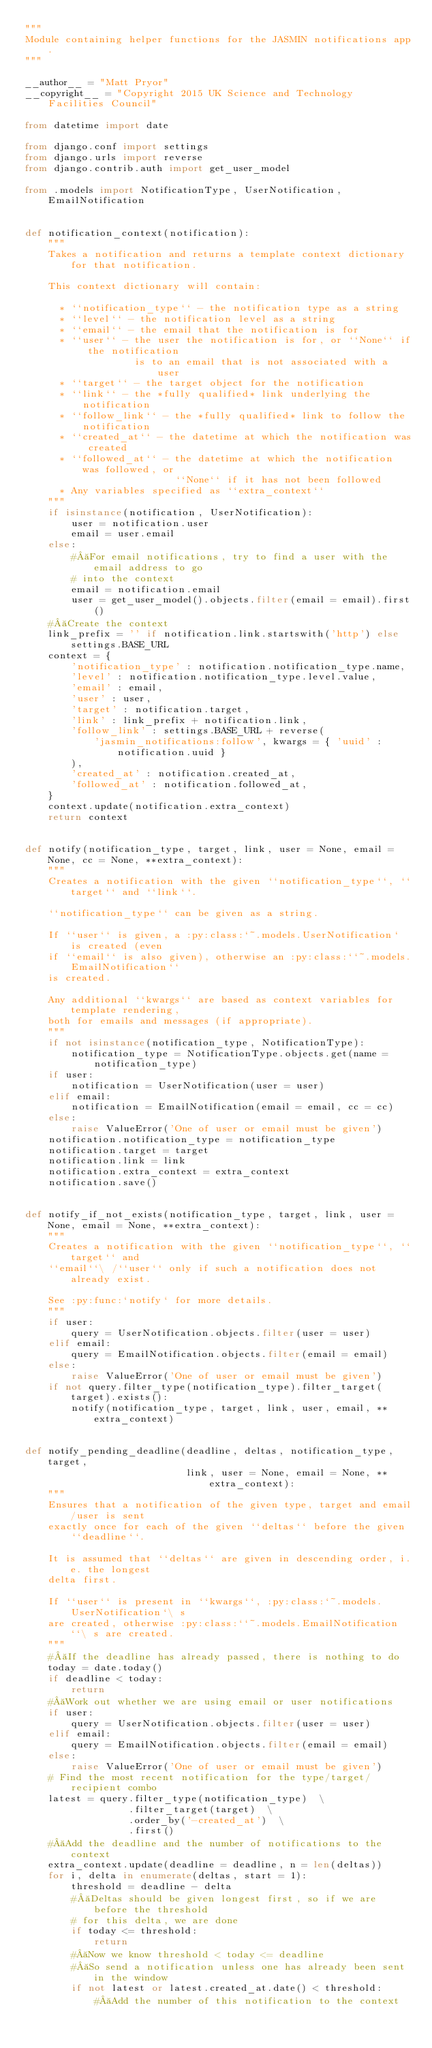Convert code to text. <code><loc_0><loc_0><loc_500><loc_500><_Python_>"""
Module containing helper functions for the JASMIN notifications app.
"""

__author__ = "Matt Pryor"
__copyright__ = "Copyright 2015 UK Science and Technology Facilities Council"

from datetime import date

from django.conf import settings
from django.urls import reverse
from django.contrib.auth import get_user_model

from .models import NotificationType, UserNotification, EmailNotification


def notification_context(notification):
    """
    Takes a notification and returns a template context dictionary for that notification.

    This context dictionary will contain:

      * ``notification_type`` - the notification type as a string
      * ``level`` - the notification level as a string
      * ``email`` - the email that the notification is for
      * ``user`` - the user the notification is for, or ``None`` if the notification
                   is to an email that is not associated with a user
      * ``target`` - the target object for the notification
      * ``link`` - the *fully qualified* link underlying the notification
      * ``follow_link`` - the *fully qualified* link to follow the notification
      * ``created_at`` - the datetime at which the notification was created
      * ``followed_at`` - the datetime at which the notification was followed, or
                          ``None`` if it has not been followed
      * Any variables specified as ``extra_context``
    """
    if isinstance(notification, UserNotification):
        user = notification.user
        email = user.email
    else:
        # For email notifications, try to find a user with the email address to go
        # into the context
        email = notification.email
        user = get_user_model().objects.filter(email = email).first()
    # Create the context
    link_prefix = '' if notification.link.startswith('http') else settings.BASE_URL
    context = {
        'notification_type' : notification.notification_type.name,
        'level' : notification.notification_type.level.value,
        'email' : email,
        'user' : user,
        'target' : notification.target,
        'link' : link_prefix + notification.link,
        'follow_link' : settings.BASE_URL + reverse(
            'jasmin_notifications:follow', kwargs = { 'uuid' : notification.uuid }
        ),
        'created_at' : notification.created_at,
        'followed_at' : notification.followed_at,
    }
    context.update(notification.extra_context)
    return context


def notify(notification_type, target, link, user = None, email = None, cc = None, **extra_context):
    """
    Creates a notification with the given ``notification_type``, ``target`` and ``link``.

    ``notification_type`` can be given as a string.

    If ``user`` is given, a :py:class:`~.models.UserNotification` is created (even
    if ``email`` is also given), otherwise an :py:class:``~.models.EmailNotification``
    is created.

    Any additional ``kwargs`` are based as context variables for template rendering,
    both for emails and messages (if appropriate).
    """
    if not isinstance(notification_type, NotificationType):
        notification_type = NotificationType.objects.get(name = notification_type)
    if user:
        notification = UserNotification(user = user)
    elif email:
        notification = EmailNotification(email = email, cc = cc)
    else:
        raise ValueError('One of user or email must be given')
    notification.notification_type = notification_type
    notification.target = target
    notification.link = link
    notification.extra_context = extra_context
    notification.save()


def notify_if_not_exists(notification_type, target, link, user = None, email = None, **extra_context):
    """
    Creates a notification with the given ``notification_type``, ``target`` and
    ``email``\ /``user`` only if such a notification does not already exist.

    See :py:func:`notify` for more details.
    """
    if user:
        query = UserNotification.objects.filter(user = user)
    elif email:
        query = EmailNotification.objects.filter(email = email)
    else:
        raise ValueError('One of user or email must be given')
    if not query.filter_type(notification_type).filter_target(target).exists():
        notify(notification_type, target, link, user, email, **extra_context)


def notify_pending_deadline(deadline, deltas, notification_type, target,
                            link, user = None, email = None, **extra_context):
    """
    Ensures that a notification of the given type, target and email/user is sent
    exactly once for each of the given ``deltas`` before the given ``deadline``.

    It is assumed that ``deltas`` are given in descending order, i.e. the longest
    delta first.

    If ``user`` is present in ``kwargs``, :py:class:`~.models.UserNotification`\ s
    are created, otherwise :py:class:``~.models.EmailNotification``\ s are created.
    """
    # If the deadline has already passed, there is nothing to do
    today = date.today()
    if deadline < today:
        return
    # Work out whether we are using email or user notifications
    if user:
        query = UserNotification.objects.filter(user = user)
    elif email:
        query = EmailNotification.objects.filter(email = email)
    else:
        raise ValueError('One of user or email must be given')
    # Find the most recent notification for the type/target/recipient combo
    latest = query.filter_type(notification_type)  \
                  .filter_target(target)  \
                  .order_by('-created_at')  \
                  .first()
    # Add the deadline and the number of notifications to the context
    extra_context.update(deadline = deadline, n = len(deltas))
    for i, delta in enumerate(deltas, start = 1):
        threshold = deadline - delta
        # Deltas should be given longest first, so if we are before the threshold
        # for this delta, we are done
        if today <= threshold:
            return
        # Now we know threshold < today <= deadline
        # So send a notification unless one has already been sent in the window
        if not latest or latest.created_at.date() < threshold:
            # Add the number of this notification to the context</code> 